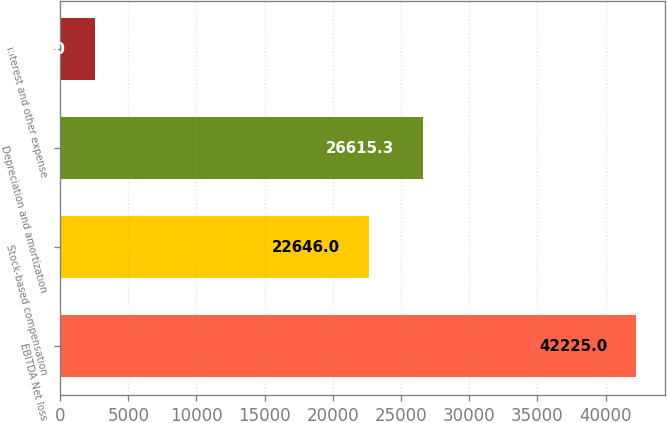Convert chart to OTSL. <chart><loc_0><loc_0><loc_500><loc_500><bar_chart><fcel>EBITDA Net loss<fcel>Stock-based compensation<fcel>Depreciation and amortization<fcel>Interest and other expense<nl><fcel>42225<fcel>22646<fcel>26615.3<fcel>2532<nl></chart> 